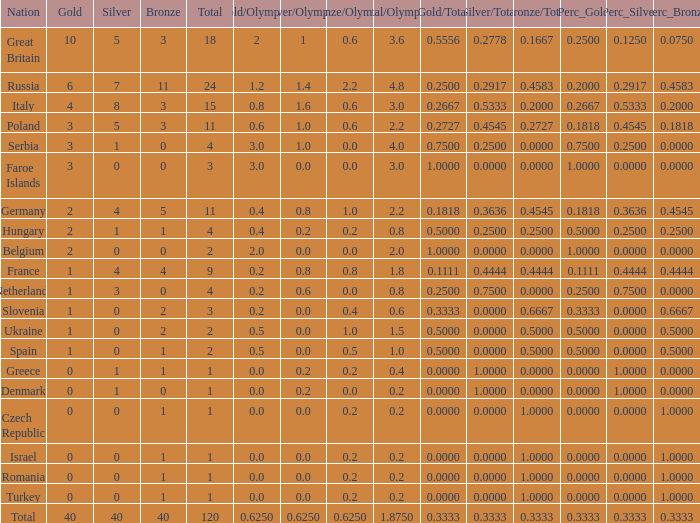What is the average Gold entry for the Netherlands that also has a Bronze entry that is greater than 0? None. 